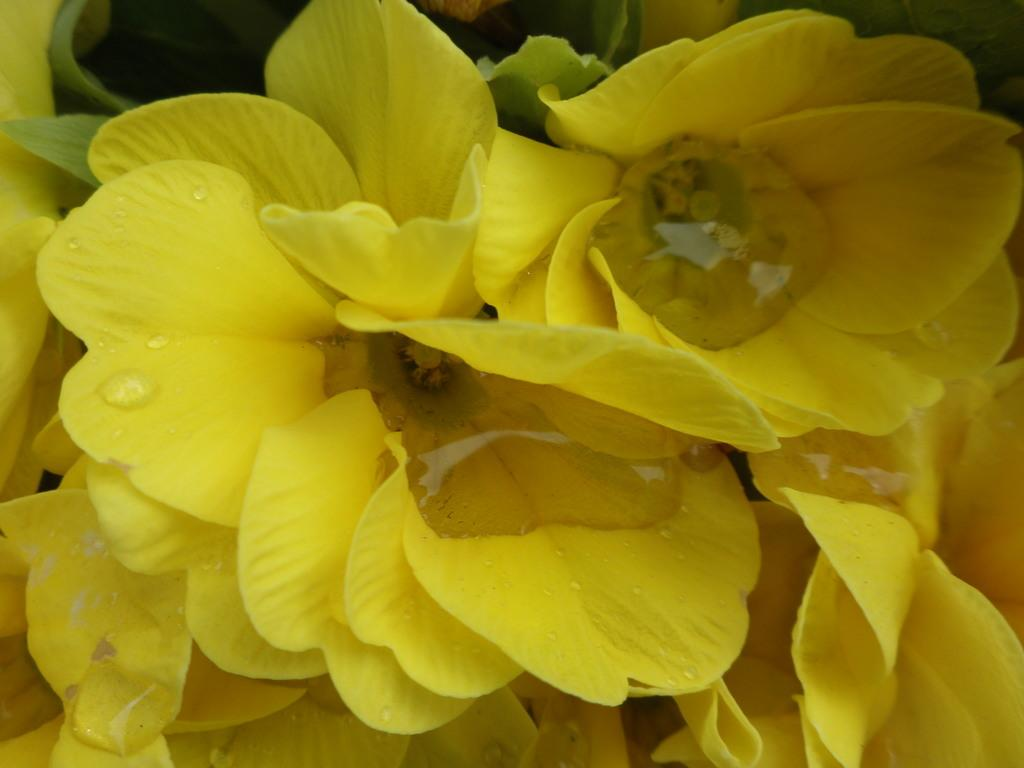What type of flowers are present in the image? There are yellow color flowers in the image. Can you describe the appearance of the flowers? The flowers have water droplets on them. What else can be seen in the image besides the flowers? There are leaves visible in the image. What is the kitten's opinion on the belief that flowers bring happiness? There is no kitten present in the image, and therefore no opinion can be attributed to it regarding the belief that flowers bring happiness. 